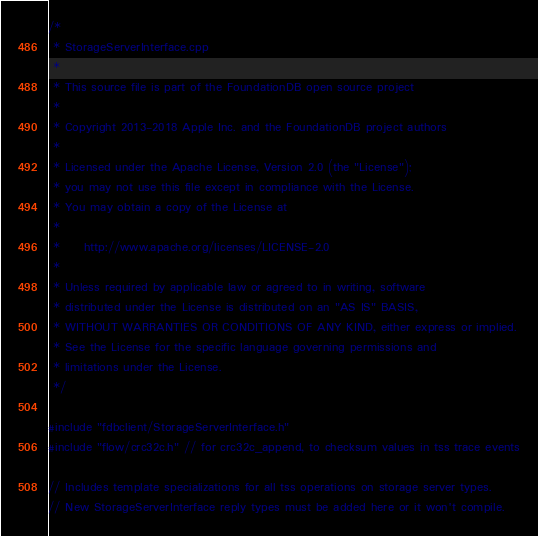<code> <loc_0><loc_0><loc_500><loc_500><_C++_>/*
 * StorageServerInterface.cpp
 *
 * This source file is part of the FoundationDB open source project
 *
 * Copyright 2013-2018 Apple Inc. and the FoundationDB project authors
 *
 * Licensed under the Apache License, Version 2.0 (the "License");
 * you may not use this file except in compliance with the License.
 * You may obtain a copy of the License at
 *
 *     http://www.apache.org/licenses/LICENSE-2.0
 *
 * Unless required by applicable law or agreed to in writing, software
 * distributed under the License is distributed on an "AS IS" BASIS,
 * WITHOUT WARRANTIES OR CONDITIONS OF ANY KIND, either express or implied.
 * See the License for the specific language governing permissions and
 * limitations under the License.
 */

#include "fdbclient/StorageServerInterface.h"
#include "flow/crc32c.h" // for crc32c_append, to checksum values in tss trace events

// Includes template specializations for all tss operations on storage server types.
// New StorageServerInterface reply types must be added here or it won't compile.
</code> 